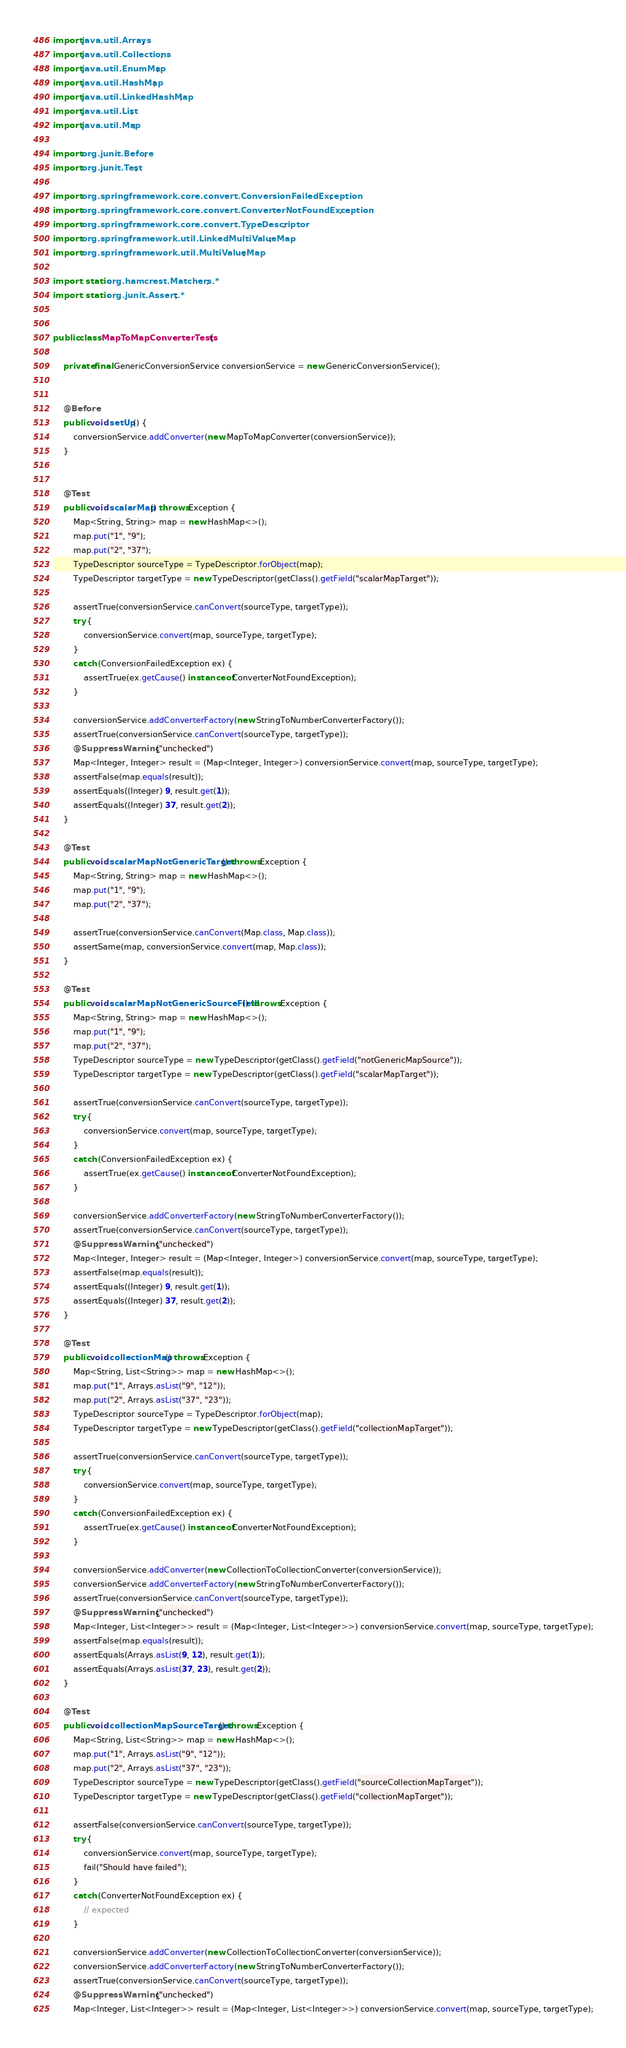<code> <loc_0><loc_0><loc_500><loc_500><_Java_>
import java.util.Arrays;
import java.util.Collections;
import java.util.EnumMap;
import java.util.HashMap;
import java.util.LinkedHashMap;
import java.util.List;
import java.util.Map;

import org.junit.Before;
import org.junit.Test;

import org.springframework.core.convert.ConversionFailedException;
import org.springframework.core.convert.ConverterNotFoundException;
import org.springframework.core.convert.TypeDescriptor;
import org.springframework.util.LinkedMultiValueMap;
import org.springframework.util.MultiValueMap;

import static org.hamcrest.Matchers.*;
import static org.junit.Assert.*;


public class MapToMapConverterTests {

	private final GenericConversionService conversionService = new GenericConversionService();


	@Before
	public void setUp() {
		conversionService.addConverter(new MapToMapConverter(conversionService));
	}


	@Test
	public void scalarMap() throws Exception {
		Map<String, String> map = new HashMap<>();
		map.put("1", "9");
		map.put("2", "37");
		TypeDescriptor sourceType = TypeDescriptor.forObject(map);
		TypeDescriptor targetType = new TypeDescriptor(getClass().getField("scalarMapTarget"));

		assertTrue(conversionService.canConvert(sourceType, targetType));
		try {
			conversionService.convert(map, sourceType, targetType);
		}
		catch (ConversionFailedException ex) {
			assertTrue(ex.getCause() instanceof ConverterNotFoundException);
		}

		conversionService.addConverterFactory(new StringToNumberConverterFactory());
		assertTrue(conversionService.canConvert(sourceType, targetType));
		@SuppressWarnings("unchecked")
		Map<Integer, Integer> result = (Map<Integer, Integer>) conversionService.convert(map, sourceType, targetType);
		assertFalse(map.equals(result));
		assertEquals((Integer) 9, result.get(1));
		assertEquals((Integer) 37, result.get(2));
	}

	@Test
	public void scalarMapNotGenericTarget() throws Exception {
		Map<String, String> map = new HashMap<>();
		map.put("1", "9");
		map.put("2", "37");

		assertTrue(conversionService.canConvert(Map.class, Map.class));
		assertSame(map, conversionService.convert(map, Map.class));
	}

	@Test
	public void scalarMapNotGenericSourceField() throws Exception {
		Map<String, String> map = new HashMap<>();
		map.put("1", "9");
		map.put("2", "37");
		TypeDescriptor sourceType = new TypeDescriptor(getClass().getField("notGenericMapSource"));
		TypeDescriptor targetType = new TypeDescriptor(getClass().getField("scalarMapTarget"));

		assertTrue(conversionService.canConvert(sourceType, targetType));
		try {
			conversionService.convert(map, sourceType, targetType);
		}
		catch (ConversionFailedException ex) {
			assertTrue(ex.getCause() instanceof ConverterNotFoundException);
		}

		conversionService.addConverterFactory(new StringToNumberConverterFactory());
		assertTrue(conversionService.canConvert(sourceType, targetType));
		@SuppressWarnings("unchecked")
		Map<Integer, Integer> result = (Map<Integer, Integer>) conversionService.convert(map, sourceType, targetType);
		assertFalse(map.equals(result));
		assertEquals((Integer) 9, result.get(1));
		assertEquals((Integer) 37, result.get(2));
	}

	@Test
	public void collectionMap() throws Exception {
		Map<String, List<String>> map = new HashMap<>();
		map.put("1", Arrays.asList("9", "12"));
		map.put("2", Arrays.asList("37", "23"));
		TypeDescriptor sourceType = TypeDescriptor.forObject(map);
		TypeDescriptor targetType = new TypeDescriptor(getClass().getField("collectionMapTarget"));

		assertTrue(conversionService.canConvert(sourceType, targetType));
		try {
			conversionService.convert(map, sourceType, targetType);
		}
		catch (ConversionFailedException ex) {
			assertTrue(ex.getCause() instanceof ConverterNotFoundException);
		}

		conversionService.addConverter(new CollectionToCollectionConverter(conversionService));
		conversionService.addConverterFactory(new StringToNumberConverterFactory());
		assertTrue(conversionService.canConvert(sourceType, targetType));
		@SuppressWarnings("unchecked")
		Map<Integer, List<Integer>> result = (Map<Integer, List<Integer>>) conversionService.convert(map, sourceType, targetType);
		assertFalse(map.equals(result));
		assertEquals(Arrays.asList(9, 12), result.get(1));
		assertEquals(Arrays.asList(37, 23), result.get(2));
	}

	@Test
	public void collectionMapSourceTarget() throws Exception {
		Map<String, List<String>> map = new HashMap<>();
		map.put("1", Arrays.asList("9", "12"));
		map.put("2", Arrays.asList("37", "23"));
		TypeDescriptor sourceType = new TypeDescriptor(getClass().getField("sourceCollectionMapTarget"));
		TypeDescriptor targetType = new TypeDescriptor(getClass().getField("collectionMapTarget"));

		assertFalse(conversionService.canConvert(sourceType, targetType));
		try {
			conversionService.convert(map, sourceType, targetType);
			fail("Should have failed");
		}
		catch (ConverterNotFoundException ex) {
			// expected
		}

		conversionService.addConverter(new CollectionToCollectionConverter(conversionService));
		conversionService.addConverterFactory(new StringToNumberConverterFactory());
		assertTrue(conversionService.canConvert(sourceType, targetType));
		@SuppressWarnings("unchecked")
		Map<Integer, List<Integer>> result = (Map<Integer, List<Integer>>) conversionService.convert(map, sourceType, targetType);</code> 